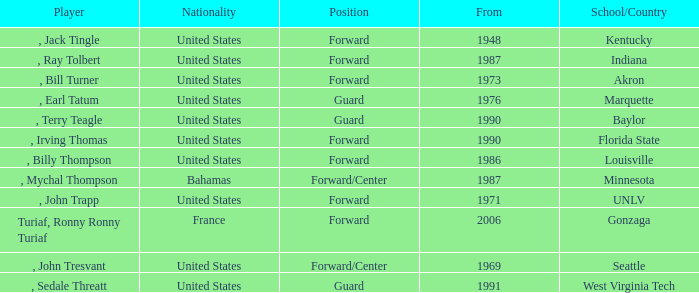What was the nationality of all players from the year 1976? United States. 